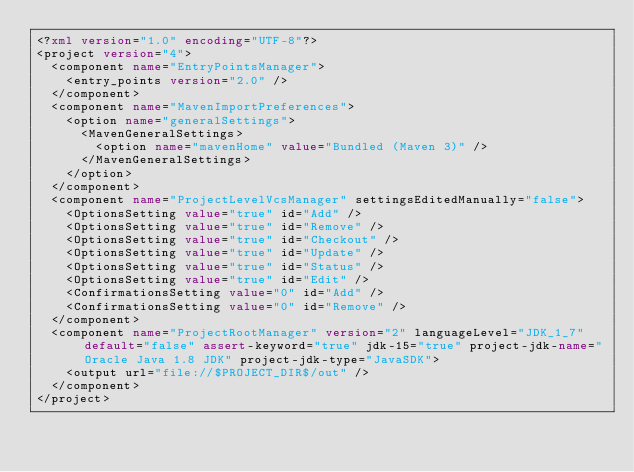Convert code to text. <code><loc_0><loc_0><loc_500><loc_500><_XML_><?xml version="1.0" encoding="UTF-8"?>
<project version="4">
  <component name="EntryPointsManager">
    <entry_points version="2.0" />
  </component>
  <component name="MavenImportPreferences">
    <option name="generalSettings">
      <MavenGeneralSettings>
        <option name="mavenHome" value="Bundled (Maven 3)" />
      </MavenGeneralSettings>
    </option>
  </component>
  <component name="ProjectLevelVcsManager" settingsEditedManually="false">
    <OptionsSetting value="true" id="Add" />
    <OptionsSetting value="true" id="Remove" />
    <OptionsSetting value="true" id="Checkout" />
    <OptionsSetting value="true" id="Update" />
    <OptionsSetting value="true" id="Status" />
    <OptionsSetting value="true" id="Edit" />
    <ConfirmationsSetting value="0" id="Add" />
    <ConfirmationsSetting value="0" id="Remove" />
  </component>
  <component name="ProjectRootManager" version="2" languageLevel="JDK_1_7" default="false" assert-keyword="true" jdk-15="true" project-jdk-name="Oracle Java 1.8 JDK" project-jdk-type="JavaSDK">
    <output url="file://$PROJECT_DIR$/out" />
  </component>
</project></code> 